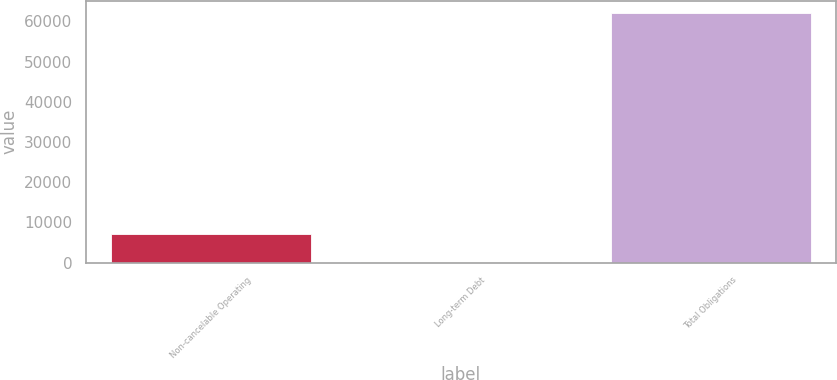Convert chart to OTSL. <chart><loc_0><loc_0><loc_500><loc_500><bar_chart><fcel>Non-cancelable Operating<fcel>Long-term Debt<fcel>Total Obligations<nl><fcel>7078<fcel>136<fcel>62014<nl></chart> 